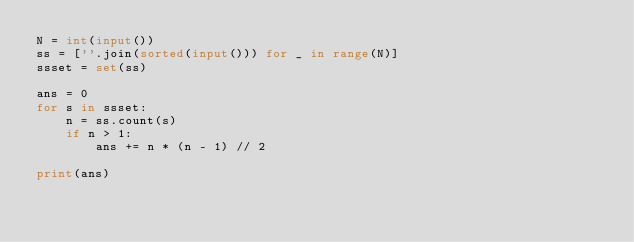<code> <loc_0><loc_0><loc_500><loc_500><_Python_>N = int(input())
ss = [''.join(sorted(input())) for _ in range(N)]
ssset = set(ss)

ans = 0
for s in ssset:
    n = ss.count(s)
    if n > 1:
        ans += n * (n - 1) // 2

print(ans)</code> 